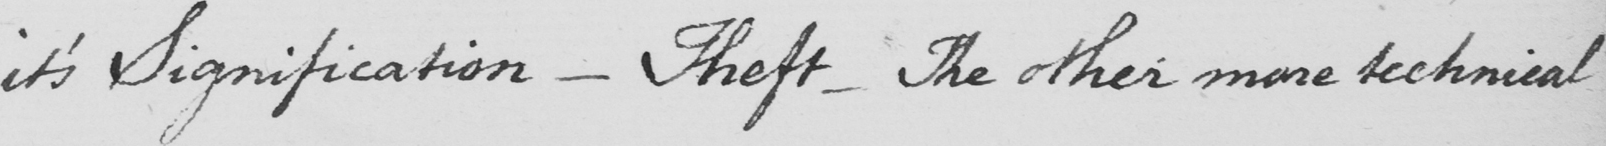Please transcribe the handwritten text in this image. it ' s Signification  _  Theft  _  The other more technical 